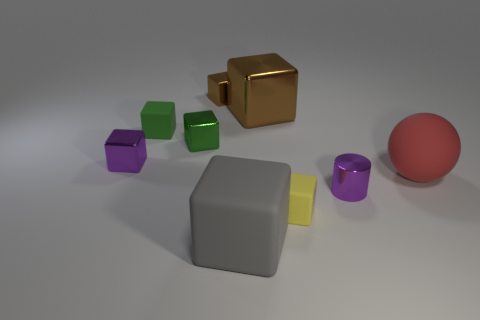Subtract all green cubes. How many cubes are left? 5 Subtract all big shiny cubes. How many cubes are left? 6 Subtract all purple cubes. Subtract all green cylinders. How many cubes are left? 6 Add 1 large brown metallic balls. How many objects exist? 10 Subtract all balls. How many objects are left? 8 Add 7 tiny spheres. How many tiny spheres exist? 7 Subtract 0 blue spheres. How many objects are left? 9 Subtract all brown rubber cubes. Subtract all gray rubber things. How many objects are left? 8 Add 5 red rubber balls. How many red rubber balls are left? 6 